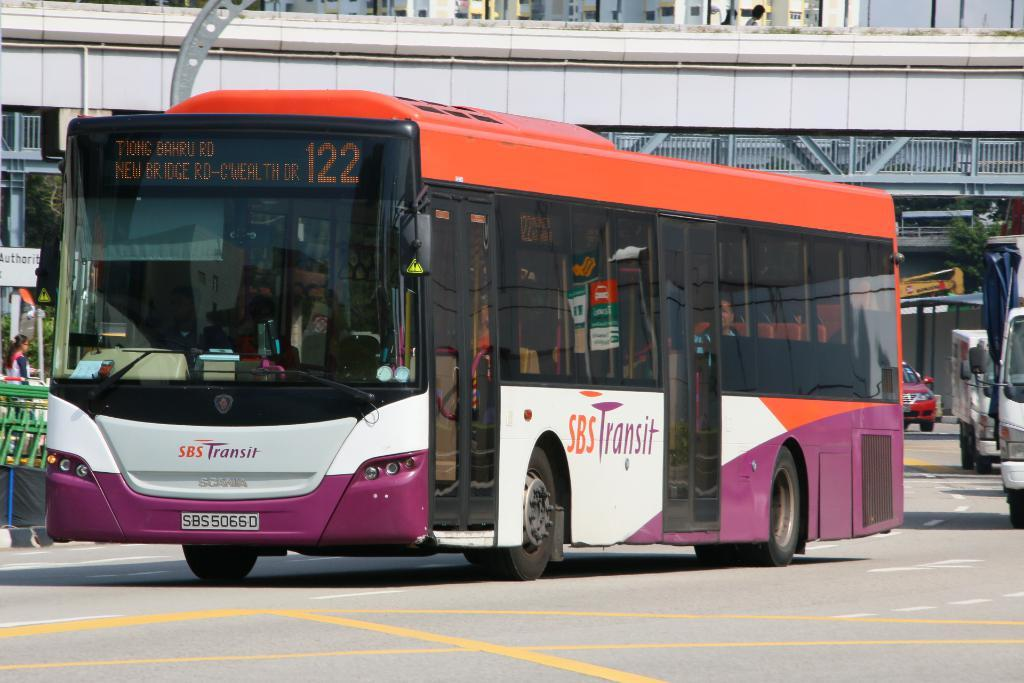<image>
Offer a succinct explanation of the picture presented. A purple, orange and white bus for SBS Transit is numbered 122. 